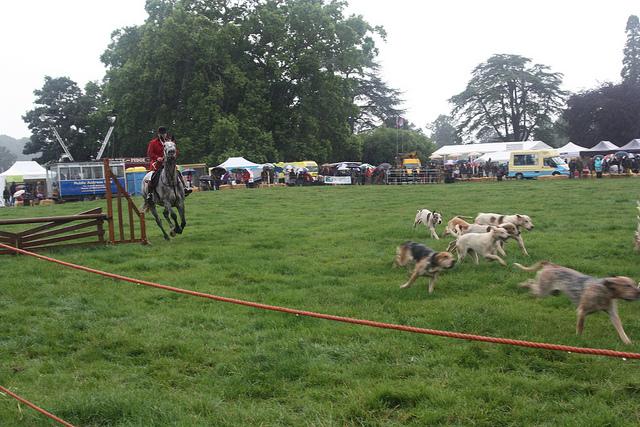The orange wire is likely being used to do what?
Give a very brief answer. Fence. What are the wooden posts for?
Write a very short answer. Jumping. What are all the animals doing?
Quick response, please. Running. 